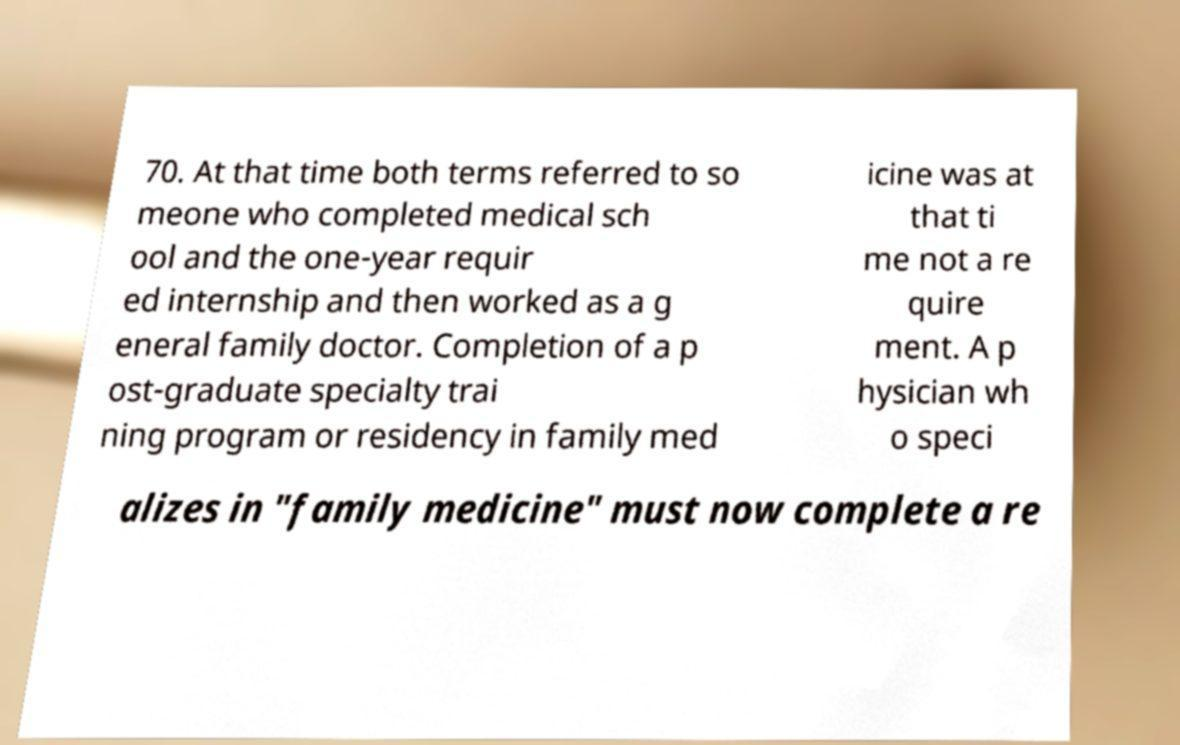Can you accurately transcribe the text from the provided image for me? 70. At that time both terms referred to so meone who completed medical sch ool and the one-year requir ed internship and then worked as a g eneral family doctor. Completion of a p ost-graduate specialty trai ning program or residency in family med icine was at that ti me not a re quire ment. A p hysician wh o speci alizes in "family medicine" must now complete a re 